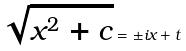Convert formula to latex. <formula><loc_0><loc_0><loc_500><loc_500>\sqrt { x ^ { 2 } + c } = \pm i x + t</formula> 